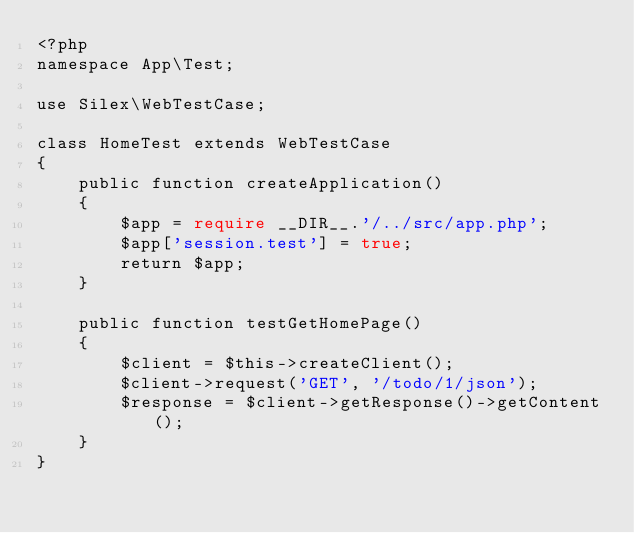Convert code to text. <code><loc_0><loc_0><loc_500><loc_500><_PHP_><?php
namespace App\Test;

use Silex\WebTestCase;

class HomeTest extends WebTestCase
{
    public function createApplication()
    {
        $app = require __DIR__.'/../src/app.php';
        $app['session.test'] = true;
        return $app;
    }

    public function testGetHomePage()
    {
        $client = $this->createClient();
        $client->request('GET', '/todo/1/json');
        $response = $client->getResponse()->getContent();
    }
}</code> 